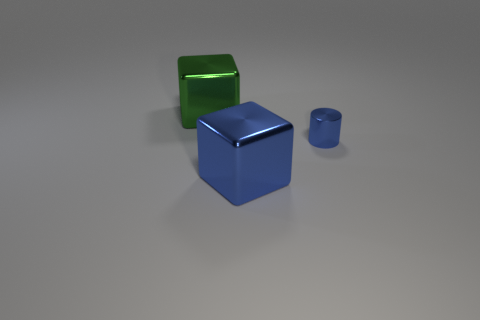Add 1 metallic things. How many objects exist? 4 Subtract all cylinders. How many objects are left? 2 Add 1 big green objects. How many big green objects exist? 2 Subtract 0 gray cubes. How many objects are left? 3 Subtract all big gray shiny objects. Subtract all green cubes. How many objects are left? 2 Add 3 large objects. How many large objects are left? 5 